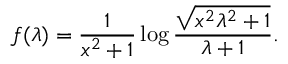<formula> <loc_0><loc_0><loc_500><loc_500>f ( \lambda ) = \frac { 1 } { x ^ { 2 } + 1 } \log \frac { \sqrt { x ^ { 2 } \lambda ^ { 2 } + 1 } } { \lambda + 1 } .</formula> 